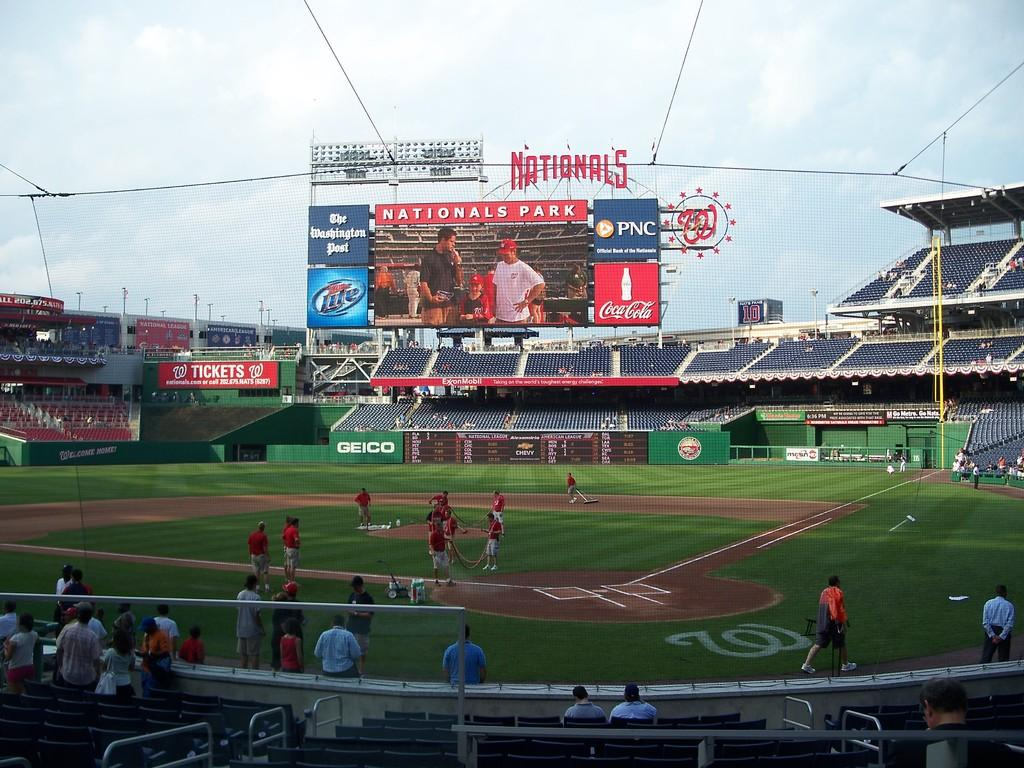<image>
Summarize the visual content of the image. A baseball field is being cleaned with a sign that says Nationals. 